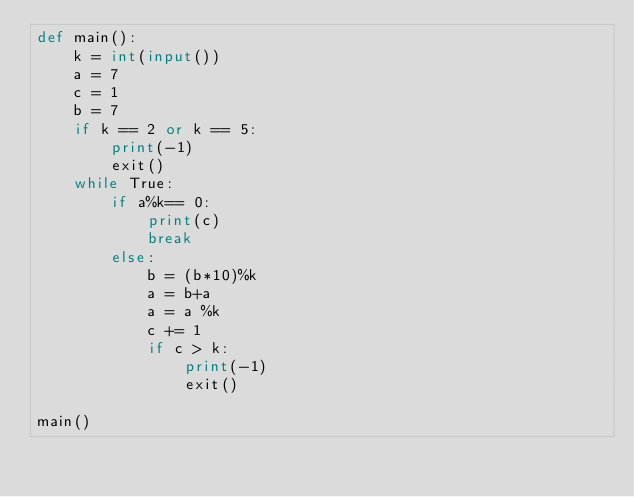<code> <loc_0><loc_0><loc_500><loc_500><_Python_>def main():
    k = int(input())
    a = 7
    c = 1
    b = 7
    if k == 2 or k == 5:
        print(-1)
        exit()
    while True:
        if a%k== 0:
            print(c)
            break
        else:
            b = (b*10)%k
            a = b+a
            a = a %k
            c += 1
            if c > k:
                print(-1)
                exit()

main()</code> 